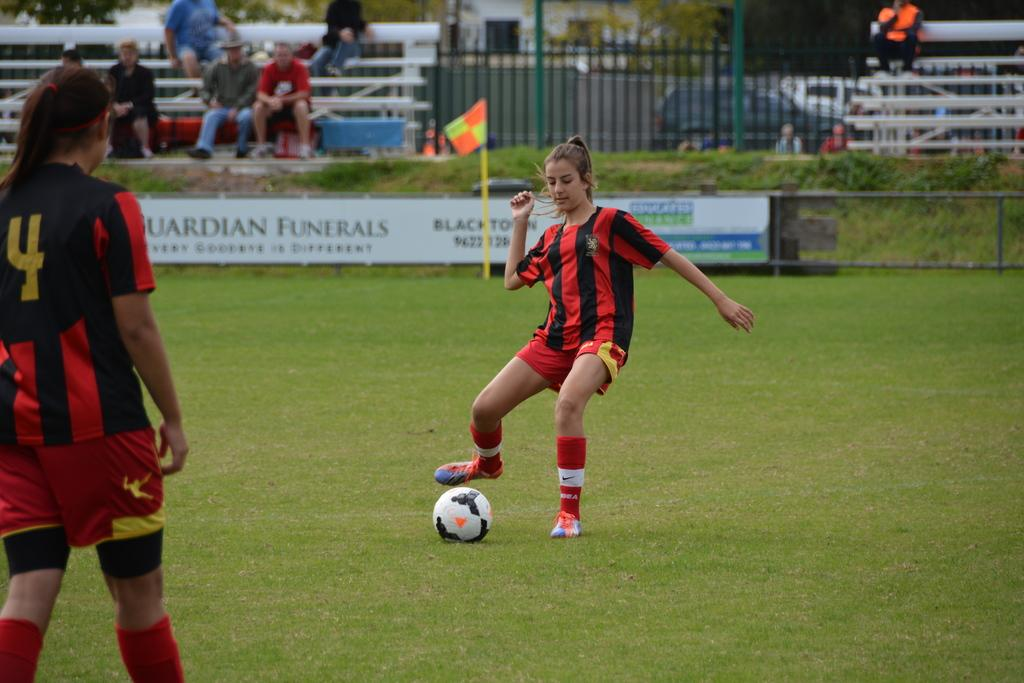<image>
Share a concise interpretation of the image provided. A soccer field with banners on the side and one reads Guardian Funerals 